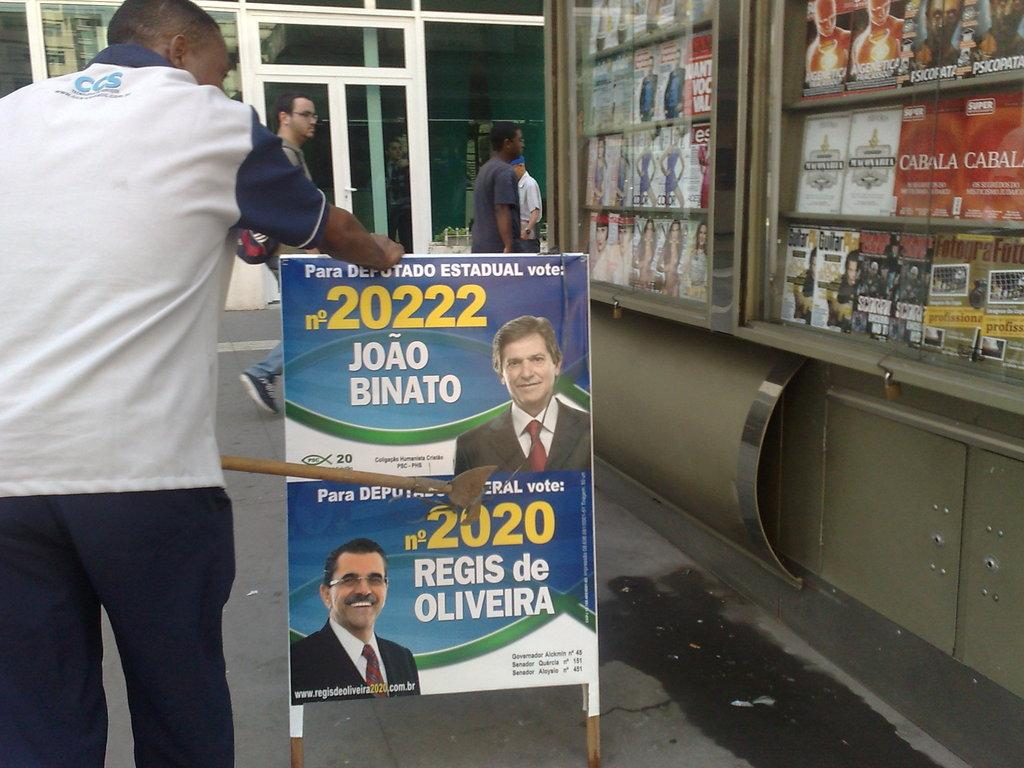What is the person in the image doing? The person is standing in the left corner of the image with their hands on a banner. What is the banner connected to or associated with? The banner has something written on it, which suggests it might be part of an event or message. What else can be seen near the banner? There are other objects beside the banner. How many giants are visible in the image? There are no giants visible in the image. What type of face can be seen on the person holding the banner? The image does not show the person's face, so it cannot be determined from the image. 